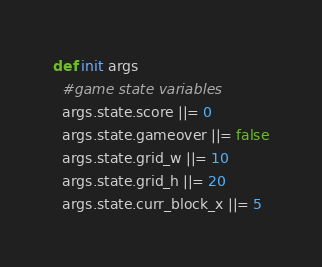Convert code to text. <code><loc_0><loc_0><loc_500><loc_500><_Ruby_>def init args
  #game state variables
  args.state.score ||= 0
  args.state.gameover ||= false
  args.state.grid_w ||= 10
  args.state.grid_h ||= 20
  args.state.curr_block_x ||= 5</code> 